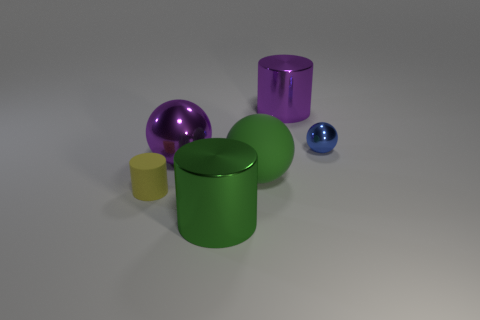Are there more big cylinders that are behind the tiny blue sphere than big purple shiny cylinders that are left of the big purple metallic cylinder?
Your answer should be compact. Yes. What shape is the purple shiny object that is the same size as the purple shiny cylinder?
Your response must be concise. Sphere. How many things are either brown matte objects or metal things behind the small shiny thing?
Your response must be concise. 1. What number of green cylinders are left of the small matte cylinder?
Offer a terse response. 0. What color is the small object that is made of the same material as the green ball?
Offer a terse response. Yellow. What number of metallic objects are either big cyan cubes or green spheres?
Provide a succinct answer. 0. Does the small yellow object have the same material as the green cylinder?
Provide a succinct answer. No. The object that is in front of the tiny yellow cylinder has what shape?
Your response must be concise. Cylinder. There is a metal cylinder behind the rubber cylinder; are there any big purple things that are right of it?
Offer a terse response. No. Is there a thing that has the same size as the green sphere?
Keep it short and to the point. Yes. 